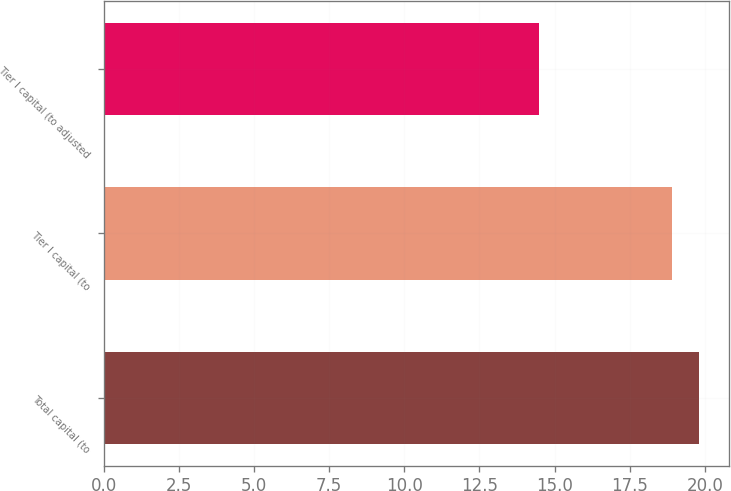<chart> <loc_0><loc_0><loc_500><loc_500><bar_chart><fcel>Total capital (to<fcel>Tier I capital (to<fcel>Tier I capital (to adjusted<nl><fcel>19.8<fcel>18.9<fcel>14.5<nl></chart> 